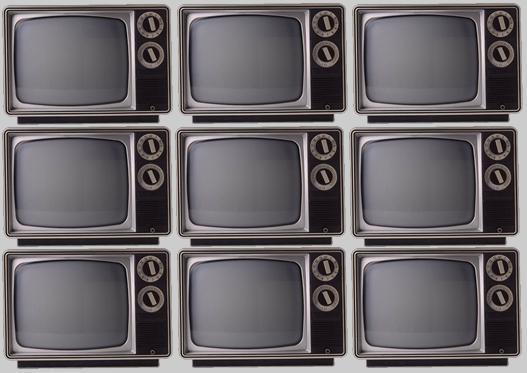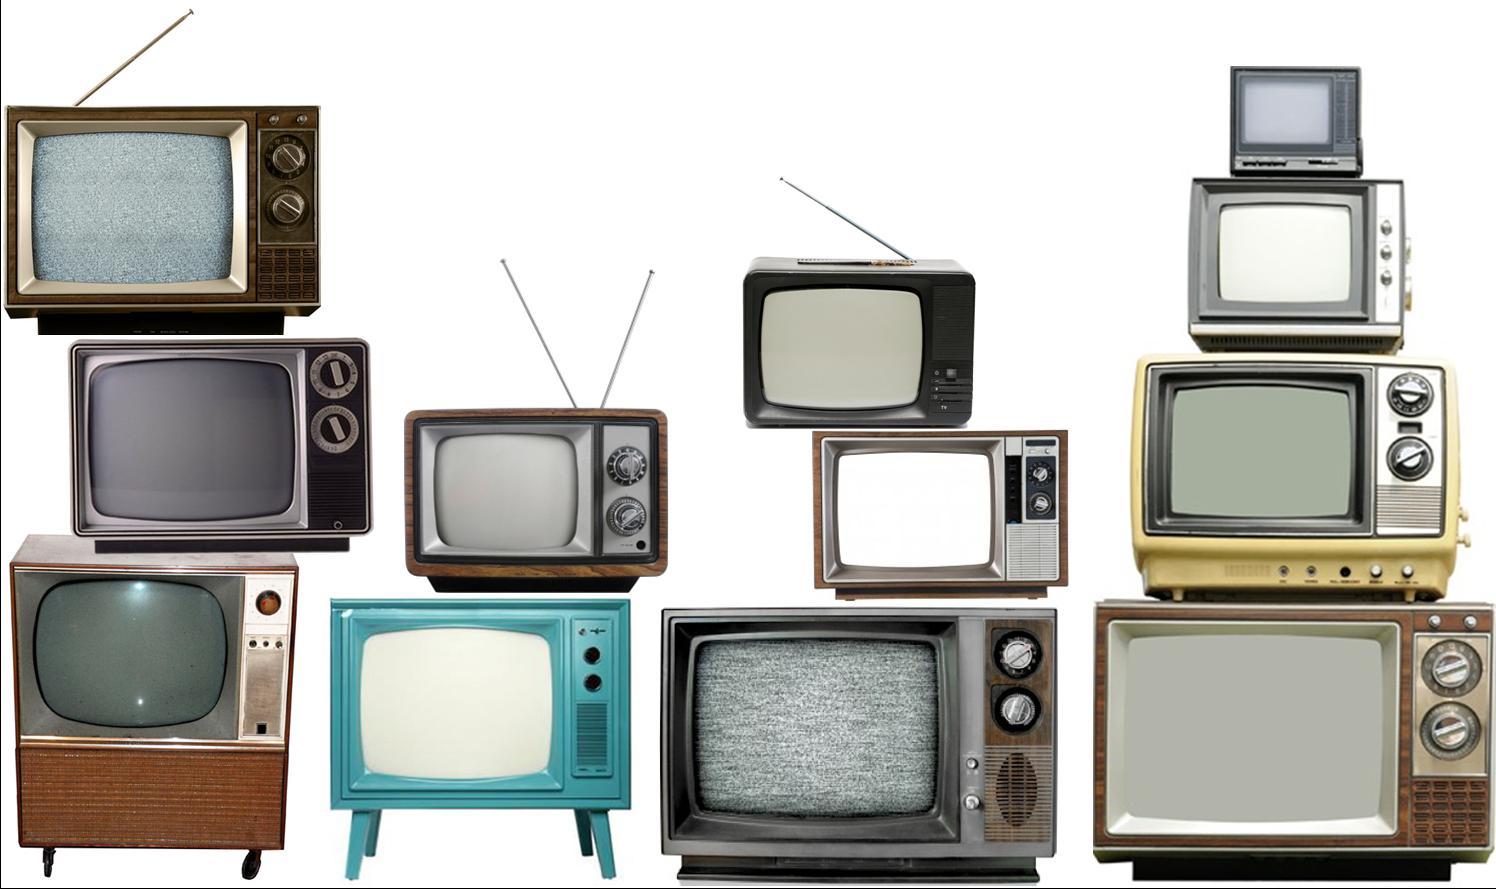The first image is the image on the left, the second image is the image on the right. Analyze the images presented: Is the assertion "There are nine identical TVs placed on each other with exactly two circle knobs on the right hand side of each of the nine televisions." valid? Answer yes or no. Yes. The first image is the image on the left, the second image is the image on the right. For the images displayed, is the sentence "There are three stacks of  televisions stacked three high next to each other." factually correct? Answer yes or no. Yes. 